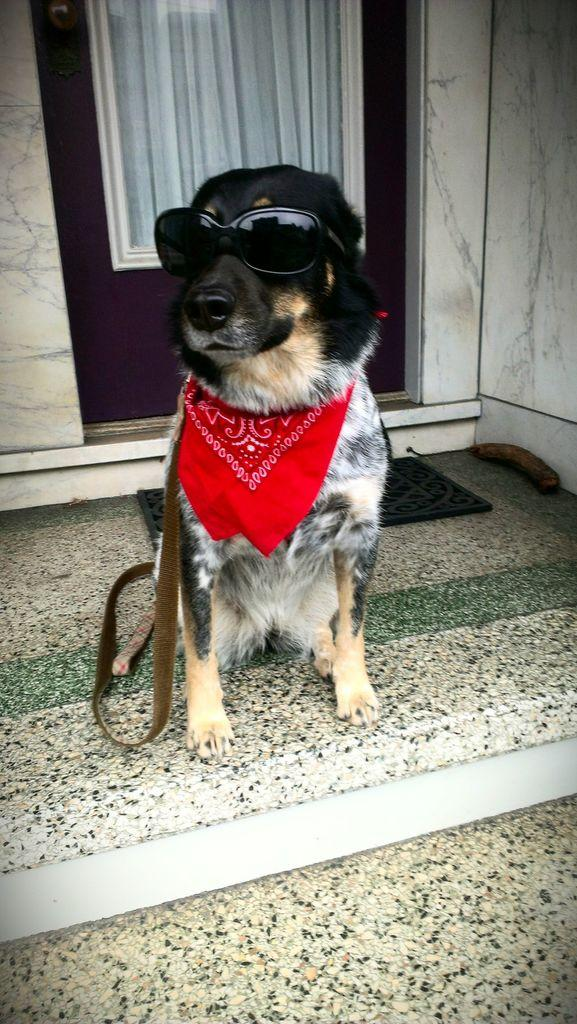What type of animal is present in the image? There is a dog in the image. What is the dog standing or sitting on? The dog is on a surface in the image. What type of accessory is visible in the image? There are goggles, a kerchief, and a belt in the image. What is present near the entrance of the room in the image? There is a door mat in the image. What type of architectural features can be seen in the background of the image? There is a wall and a door in the background of the image, along with curtains. How does the dog react to the earthquake in the image? There is no earthquake present in the image, so the dog's reaction cannot be determined. What type of vegetable is the dog holding in the image? There is no vegetable, such as celery, present in the image. 